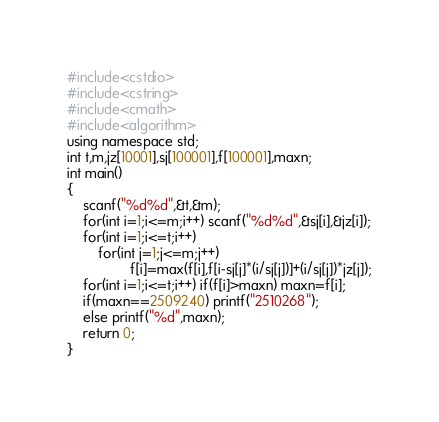<code> <loc_0><loc_0><loc_500><loc_500><_C++_>#include<cstdio>
#include<cstring>
#include<cmath>
#include<algorithm>
using namespace std;
int t,m,jz[10001],sj[100001],f[100001],maxn;
int main()
{
	scanf("%d%d",&t,&m);
	for(int i=1;i<=m;i++) scanf("%d%d",&sj[i],&jz[i]);
	for(int i=1;i<=t;i++)
		for(int j=1;j<=m;j++)
				f[i]=max(f[i],f[i-sj[j]*(i/sj[j])]+(i/sj[j])*jz[j]);
	for(int i=1;i<=t;i++) if(f[i]>maxn) maxn=f[i];
	if(maxn==2509240) printf("2510268");
	else printf("%d",maxn);
	return 0;
}</code> 